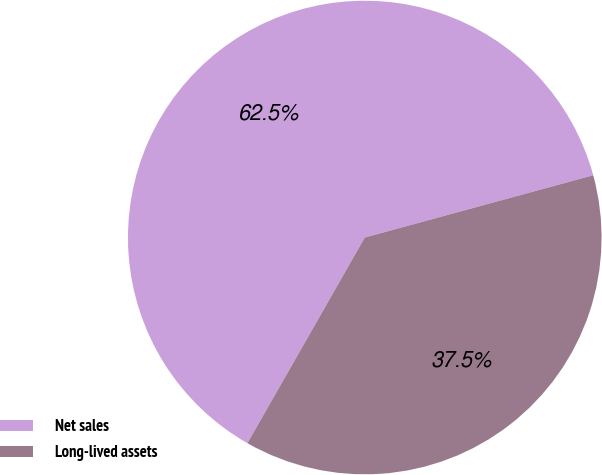<chart> <loc_0><loc_0><loc_500><loc_500><pie_chart><fcel>Net sales<fcel>Long-lived assets<nl><fcel>62.51%<fcel>37.49%<nl></chart> 